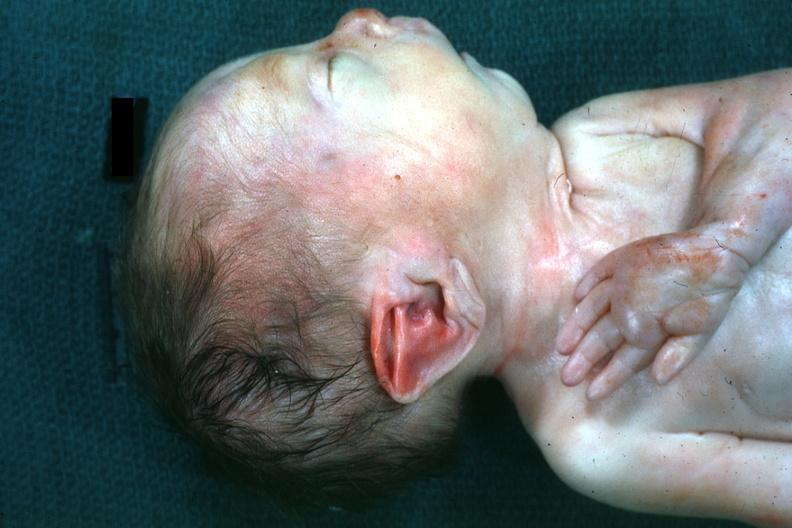what is present?
Answer the question using a single word or phrase. Face 